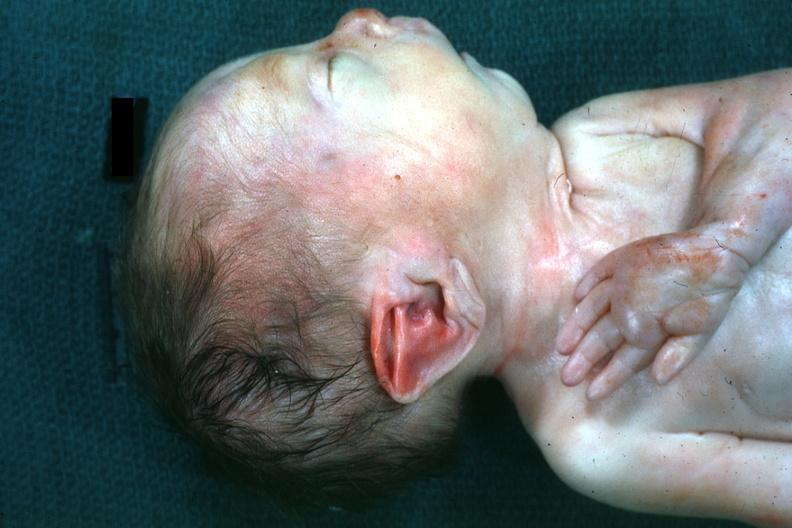what is present?
Answer the question using a single word or phrase. Face 